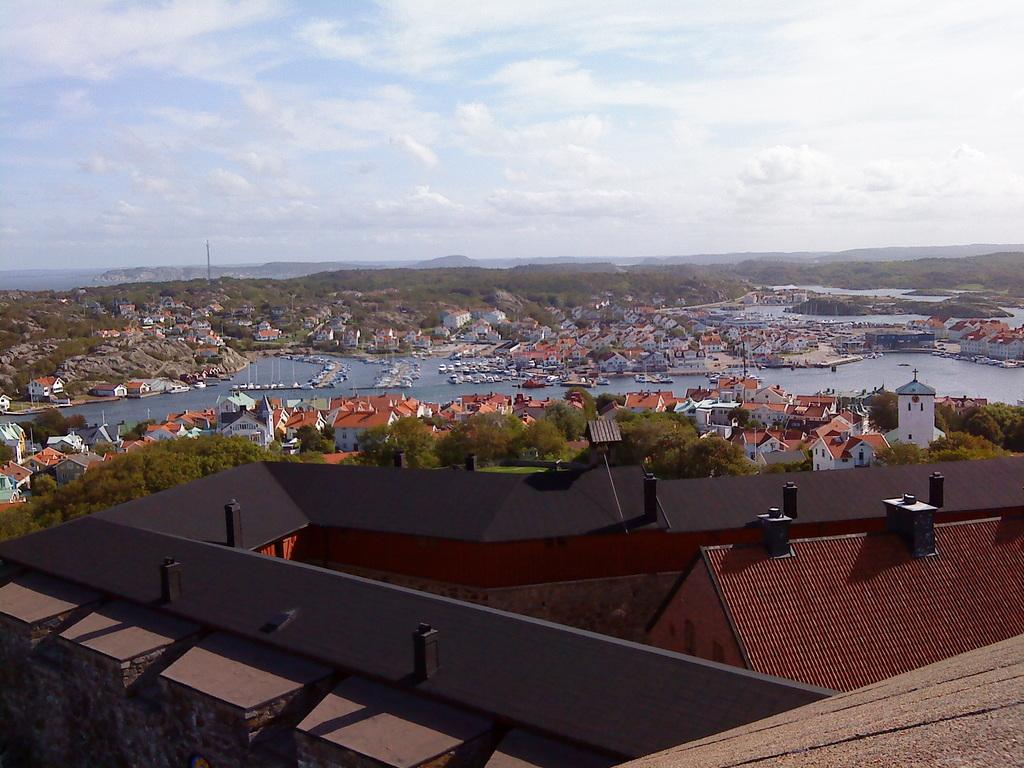What type of structures can be seen in the image? There are buildings in the image. What other natural elements are present in the image? There are trees in the image. What is located in the center of the image? There is water in the center of the image. What is floating on the water in the image? Boats are present on the water. What can be seen in the background of the image? The sky is visible in the background of the image. Can you tell me how many bees are buzzing around the trees in the image? There are no bees present in the image; it only features buildings, trees, water, boats, and the sky. What type of gold object can be seen in the image? There is no gold object present in the image. 